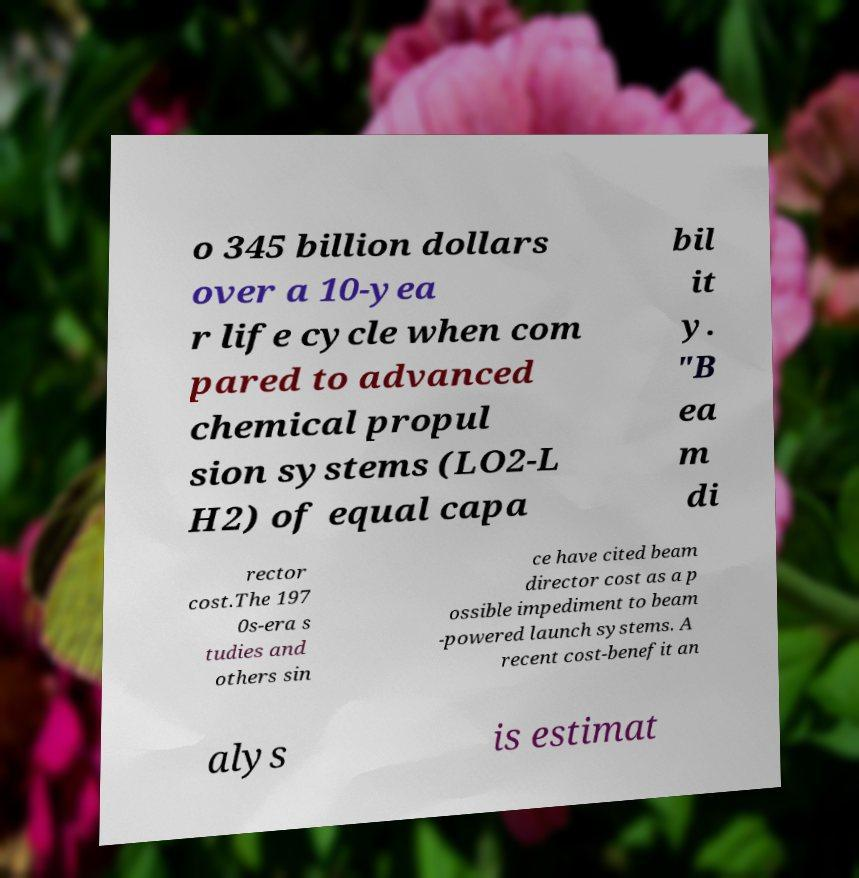Please identify and transcribe the text found in this image. o 345 billion dollars over a 10-yea r life cycle when com pared to advanced chemical propul sion systems (LO2-L H2) of equal capa bil it y. "B ea m di rector cost.The 197 0s-era s tudies and others sin ce have cited beam director cost as a p ossible impediment to beam -powered launch systems. A recent cost-benefit an alys is estimat 